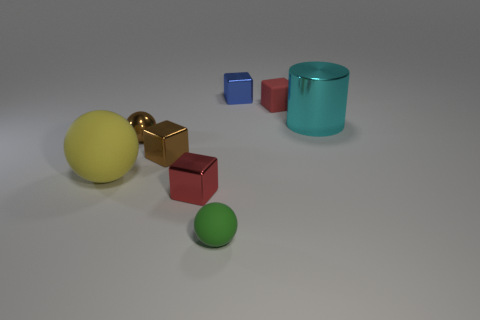Subtract all cyan cubes. Subtract all green cylinders. How many cubes are left? 4 Add 1 tiny purple metal balls. How many objects exist? 9 Subtract all cylinders. How many objects are left? 7 Add 2 tiny brown metal cubes. How many tiny brown metal cubes are left? 3 Add 2 yellow metallic objects. How many yellow metallic objects exist? 2 Subtract 0 yellow blocks. How many objects are left? 8 Subtract all small brown metallic cubes. Subtract all tiny green rubber blocks. How many objects are left? 7 